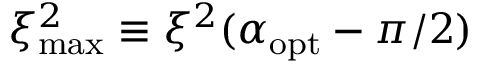Convert formula to latex. <formula><loc_0><loc_0><loc_500><loc_500>{ { \xi ^ { 2 } } _ { \max } } \equiv { \xi ^ { 2 } } ( { \alpha _ { o p t } } - \pi / 2 )</formula> 